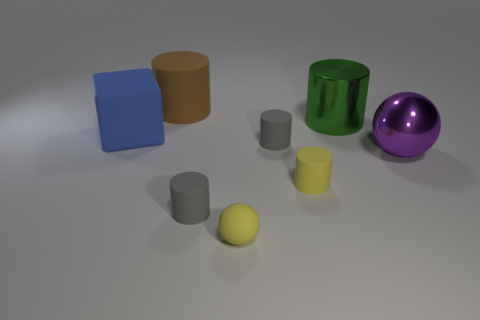Subtract all big brown cylinders. How many cylinders are left? 4 Subtract 1 balls. How many balls are left? 1 Subtract all blocks. How many objects are left? 7 Add 6 large blue blocks. How many large blue blocks are left? 7 Add 6 blue cubes. How many blue cubes exist? 7 Add 2 blue matte objects. How many objects exist? 10 Subtract all purple spheres. How many spheres are left? 1 Subtract 0 gray balls. How many objects are left? 8 Subtract all brown blocks. Subtract all yellow cylinders. How many blocks are left? 1 Subtract all red balls. How many yellow cylinders are left? 1 